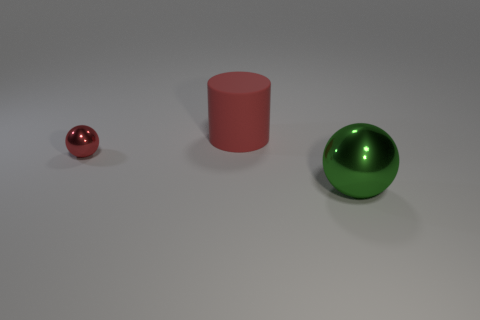There is another object that is the same size as the rubber thing; what shape is it? The object that matches the size of the rubber sphere is cylindrical in shape, with a smooth, flat top and bottom, and a curved surface extending between them. 